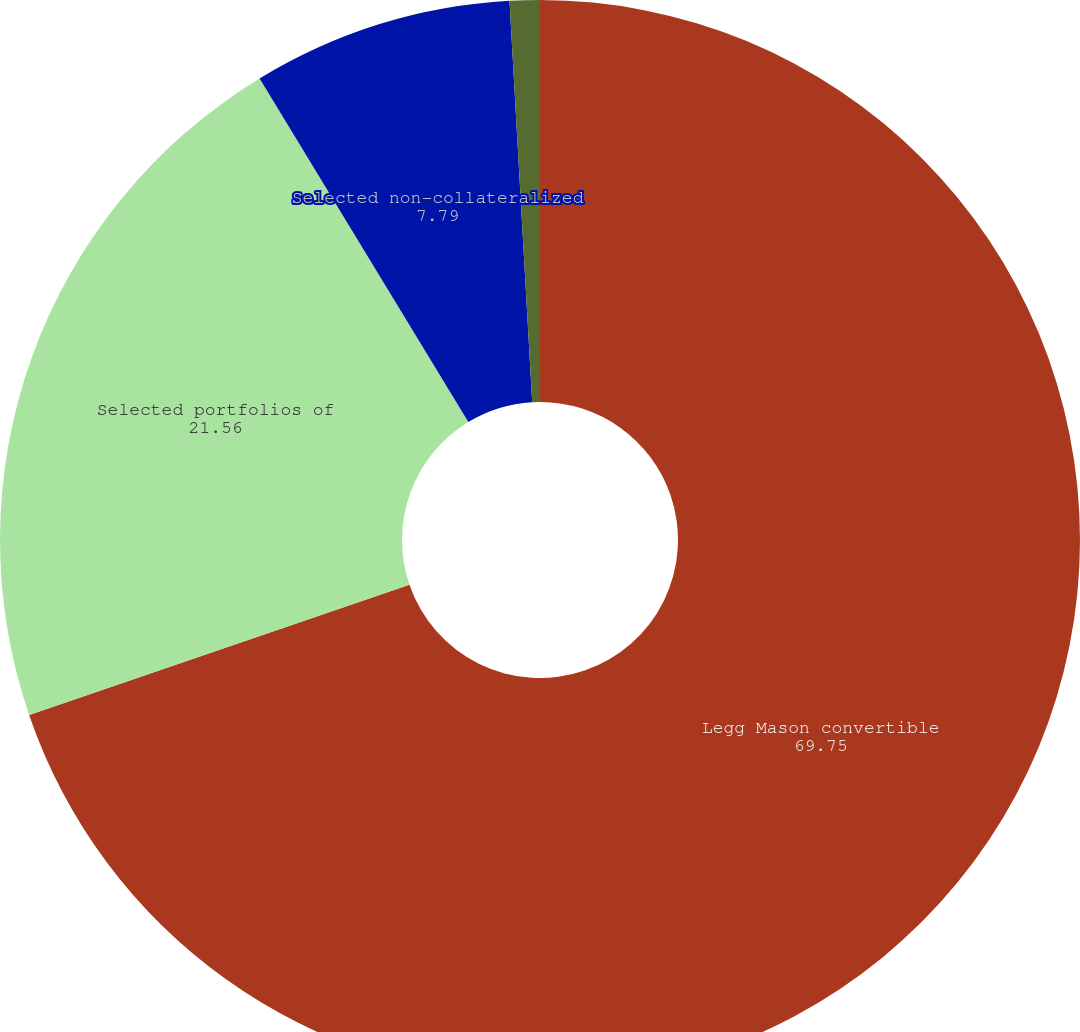Convert chart to OTSL. <chart><loc_0><loc_0><loc_500><loc_500><pie_chart><fcel>Legg Mason convertible<fcel>Selected portfolios of<fcel>Selected non-collateralized<fcel>Various miscellaneous eligible<nl><fcel>69.75%<fcel>21.56%<fcel>7.79%<fcel>0.9%<nl></chart> 